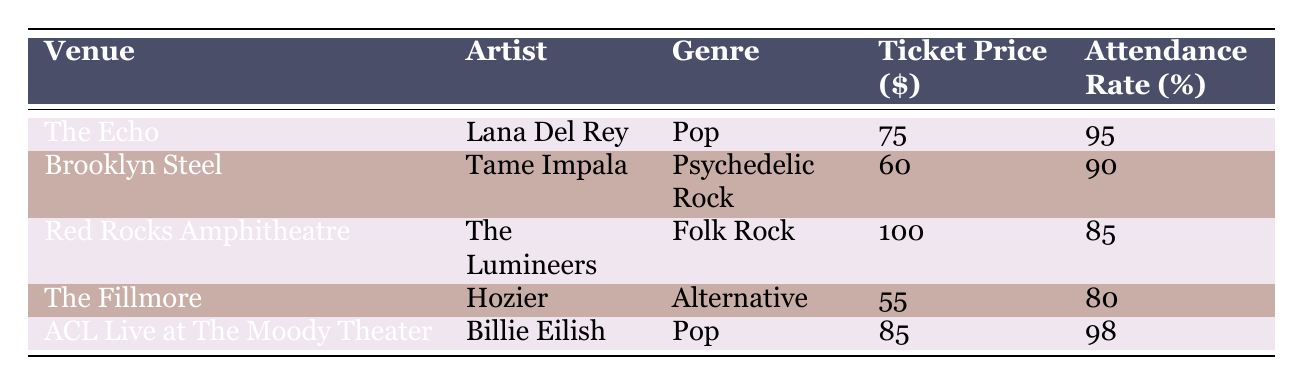What is the ticket price for Lana Del Rey's concert at The Echo? The ticket price for Lana Del Rey's concert, as shown in the table under The Echo venue, is listed as 75 dollars.
Answer: 75 Which artist performed at Brooklyn Steel? The artist that performed at Brooklyn Steel is Tame Impala, as indicated in the corresponding row of the table.
Answer: Tame Impala What is the attendance rate for Hozier's concert? Hozier's concert at The Fillmore has an attendance rate of 80 percent, according to the data in the table.
Answer: 80 Is the attendance rate for Billie Eilish higher than that for The Lumineers? The attendance rate for Billie Eilish is 98 percent, while the rate for The Lumineers is 85 percent. Since 98 is greater than 85, the answer is yes.
Answer: Yes What is the total revenue generated from the concerts held at ACL Live at The Moody Theater? The total revenue for Billie Eilish's concert at ACL Live at The Moody Theater is recorded as 425,000 dollars in the table.
Answer: 425000 Calculate the average ticket price for the concerts listed in the table. The ticket prices for the concerts are 75, 60, 100, 55, and 85 dollars. The sum of these prices is 75 + 60 + 100 + 55 + 85 = 375. There are 5 concerts, so the average ticket price is 375/5 = 75.
Answer: 75 Which venue had the highest sold tickets, and how many were sold? Red Rocks Amphitheatre had the highest sold tickets, totaling 9,500 sold tickets as noted in the table.
Answer: Red Rocks Amphitheatre, 9500 Check if The Fillmore had a higher attendance rate than Brooklyn Steel. The attendance rate for The Fillmore is 80 percent while Brooklyn Steel has a rate of 90 percent. Since 80 is less than 90, The Fillmore does not have a higher attendance rate than Brooklyn Steel.
Answer: No What is the total revenue generated by concerts in the Pop genre? The total revenue for Pop concerts can be calculated by adding the revenues from Lana Del Rey’s and Billie Eilish’s performances: 112,500 + 425,000 = 537,500 dollars.
Answer: 537500 